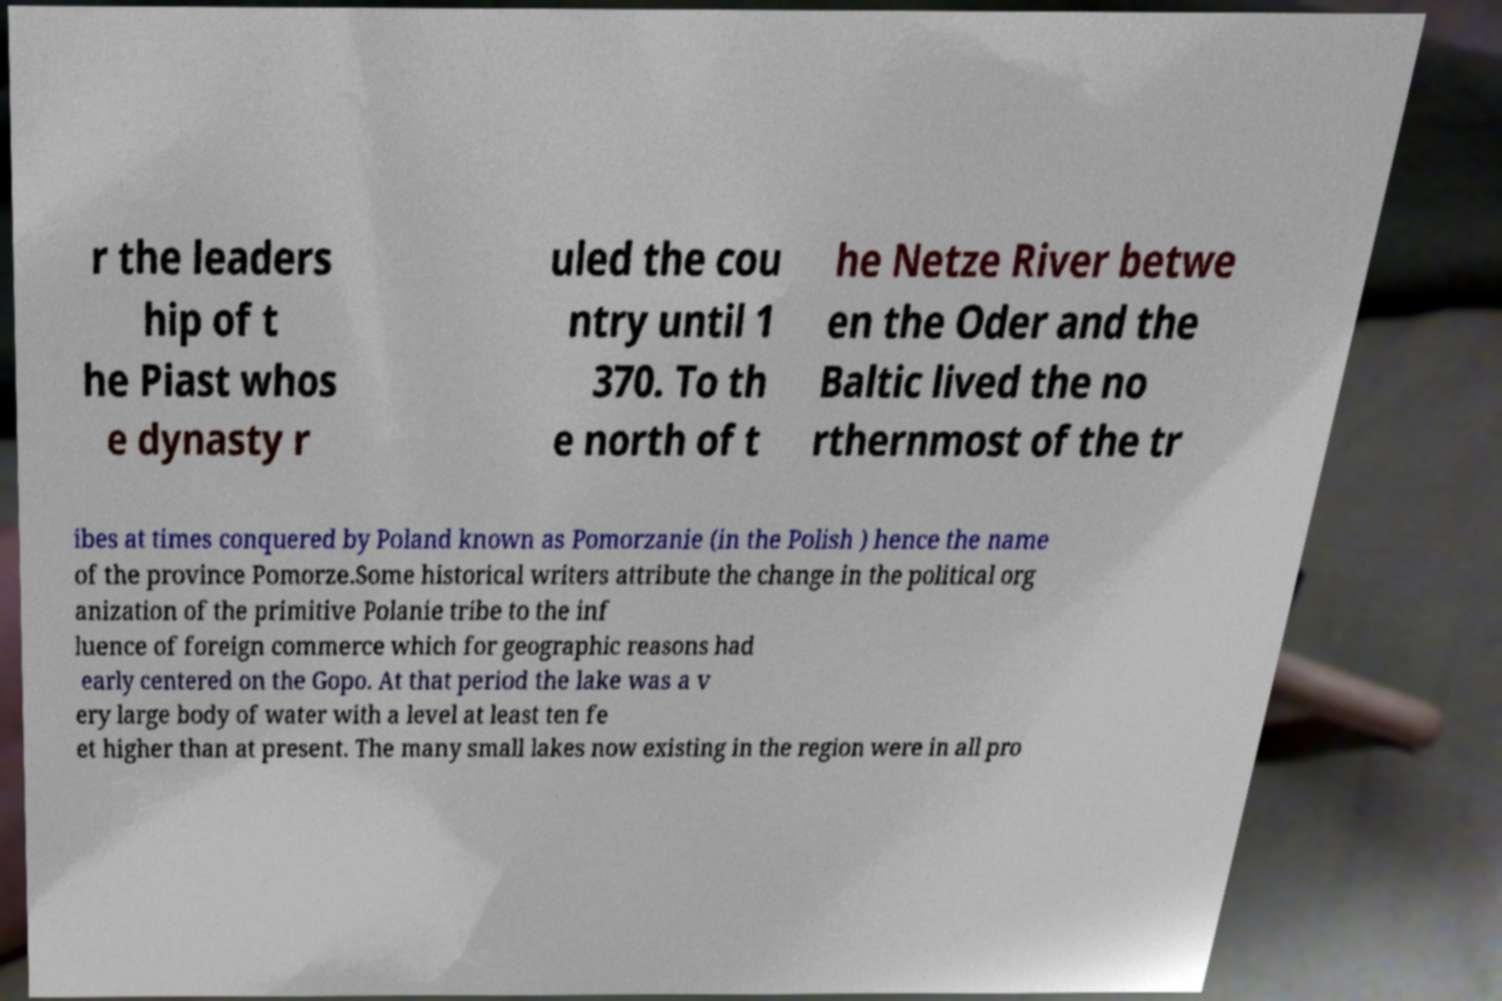I need the written content from this picture converted into text. Can you do that? r the leaders hip of t he Piast whos e dynasty r uled the cou ntry until 1 370. To th e north of t he Netze River betwe en the Oder and the Baltic lived the no rthernmost of the tr ibes at times conquered by Poland known as Pomorzanie (in the Polish ) hence the name of the province Pomorze.Some historical writers attribute the change in the political org anization of the primitive Polanie tribe to the inf luence of foreign commerce which for geographic reasons had early centered on the Gopo. At that period the lake was a v ery large body of water with a level at least ten fe et higher than at present. The many small lakes now existing in the region were in all pro 